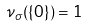Convert formula to latex. <formula><loc_0><loc_0><loc_500><loc_500>\nu _ { \sigma } ( \{ 0 \} ) = 1</formula> 